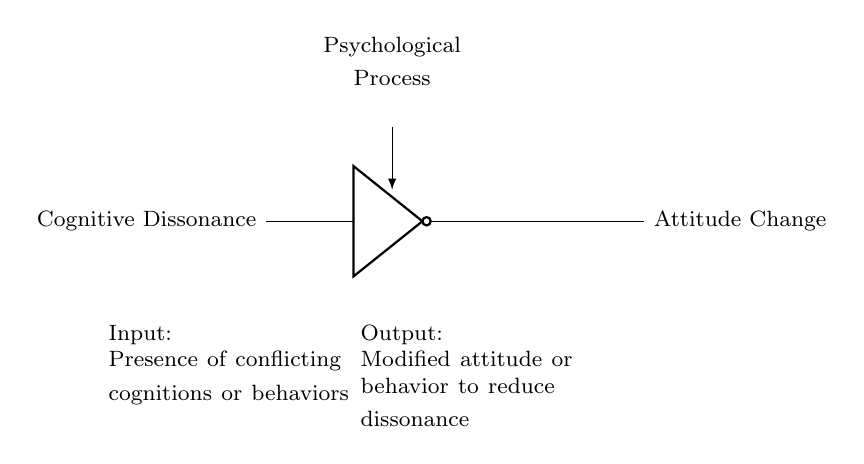What is the input of the NOT gate? The input of the NOT gate is labeled "Cognitive Dissonance," which represents conflicting thoughts or behaviors.
Answer: Cognitive Dissonance What is the output of the NOT gate? The output of the NOT gate is labeled "Attitude Change," indicating a modification in attitude or behavior resulting from the processing of the input.
Answer: Attitude Change What type of circuit is represented? The circuit is a NOT gate, which inverts the input signal, characteristic of logic gate circuits.
Answer: NOT gate What psychological process does this circuit represent? The circuit represents the psychological process of cognitive dissonance and the subsequent change in attitude or behavior.
Answer: Psychological Process How does the NOT gate transform the input? The NOT gate inverts the input "Cognitive Dissonance" into "Attitude Change," suggesting a shift from conflicting cognitions to a modified stance.
Answer: Inversion What are the additional notes provided in the diagram? The additional notes explain that the input is the presence of conflicting cognitions or behaviors, and the output is the modified attitude to reduce dissonance.
Answer: Conflicting cognitions or behaviors 